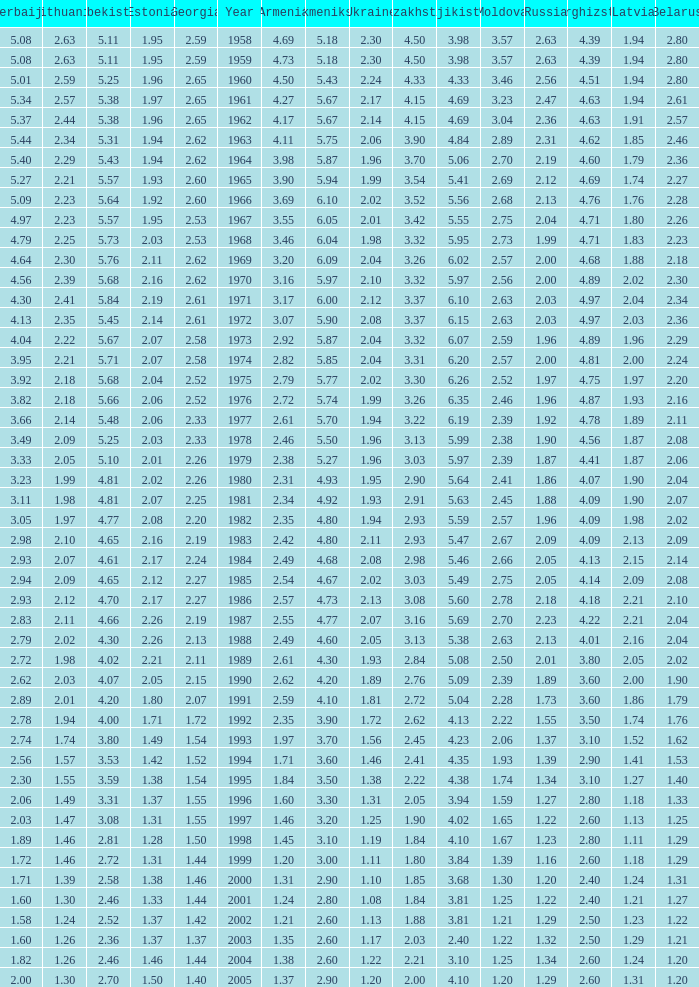Tell me the lowest kazakhstan for kyrghizstan of 4.62 and belarus less than 2.46 None. 